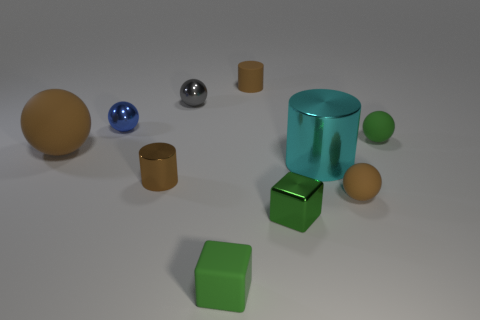There is a gray object that is the same size as the green rubber cube; what material is it?
Keep it short and to the point. Metal. The tiny blue metallic thing has what shape?
Keep it short and to the point. Sphere. What number of other gray shiny objects have the same shape as the big metallic thing?
Provide a short and direct response. 0. Are there fewer tiny metal things in front of the large cyan object than blue spheres left of the gray metallic object?
Your answer should be very brief. No. How many blue objects are left of the small matte object that is in front of the green metallic thing?
Offer a terse response. 1. Are any tiny brown cylinders visible?
Your answer should be very brief. Yes. Are there any big brown objects that have the same material as the large ball?
Keep it short and to the point. No. Are there more cylinders that are right of the green ball than small blue balls that are to the right of the green rubber cube?
Make the answer very short. No. Is the green metal cube the same size as the cyan metal thing?
Keep it short and to the point. No. There is a sphere that is in front of the large thing on the left side of the green shiny block; what color is it?
Keep it short and to the point. Brown. 